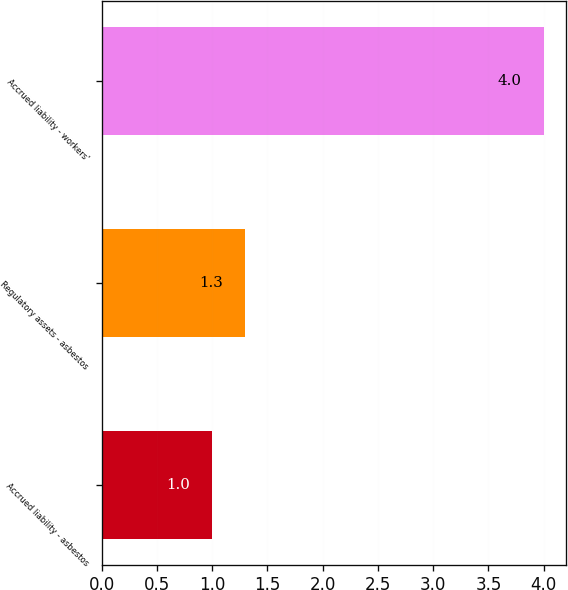Convert chart to OTSL. <chart><loc_0><loc_0><loc_500><loc_500><bar_chart><fcel>Accrued liability - asbestos<fcel>Regulatory assets - asbestos<fcel>Accrued liability - workers'<nl><fcel>1<fcel>1.3<fcel>4<nl></chart> 